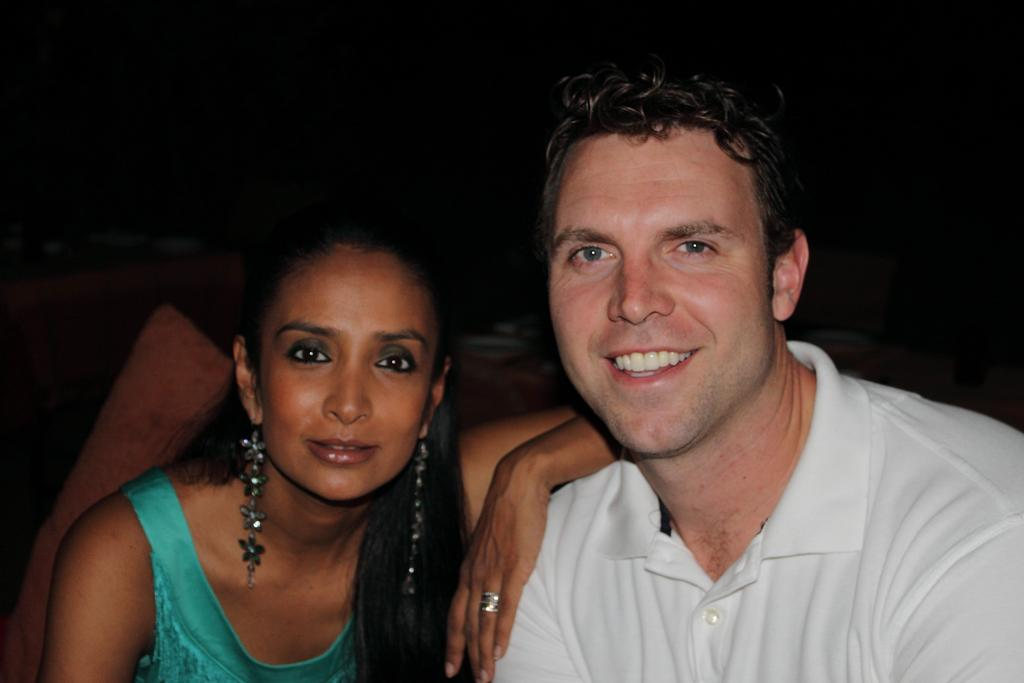How many people are in the image? There are two people in the image. What colors are the dresses worn by the people in the image? One person is wearing a white dress, and the other person is wearing a blue dress. What is the color of the background in the image? The background of the image is dark. How many babies are visible in the image? There are no babies present in the image. What type of bag is being used by one of the people in the image? There is no bag visible in the image. What musical instrument is being played by one of the people in the image? There is no musical instrument visible in the image. 